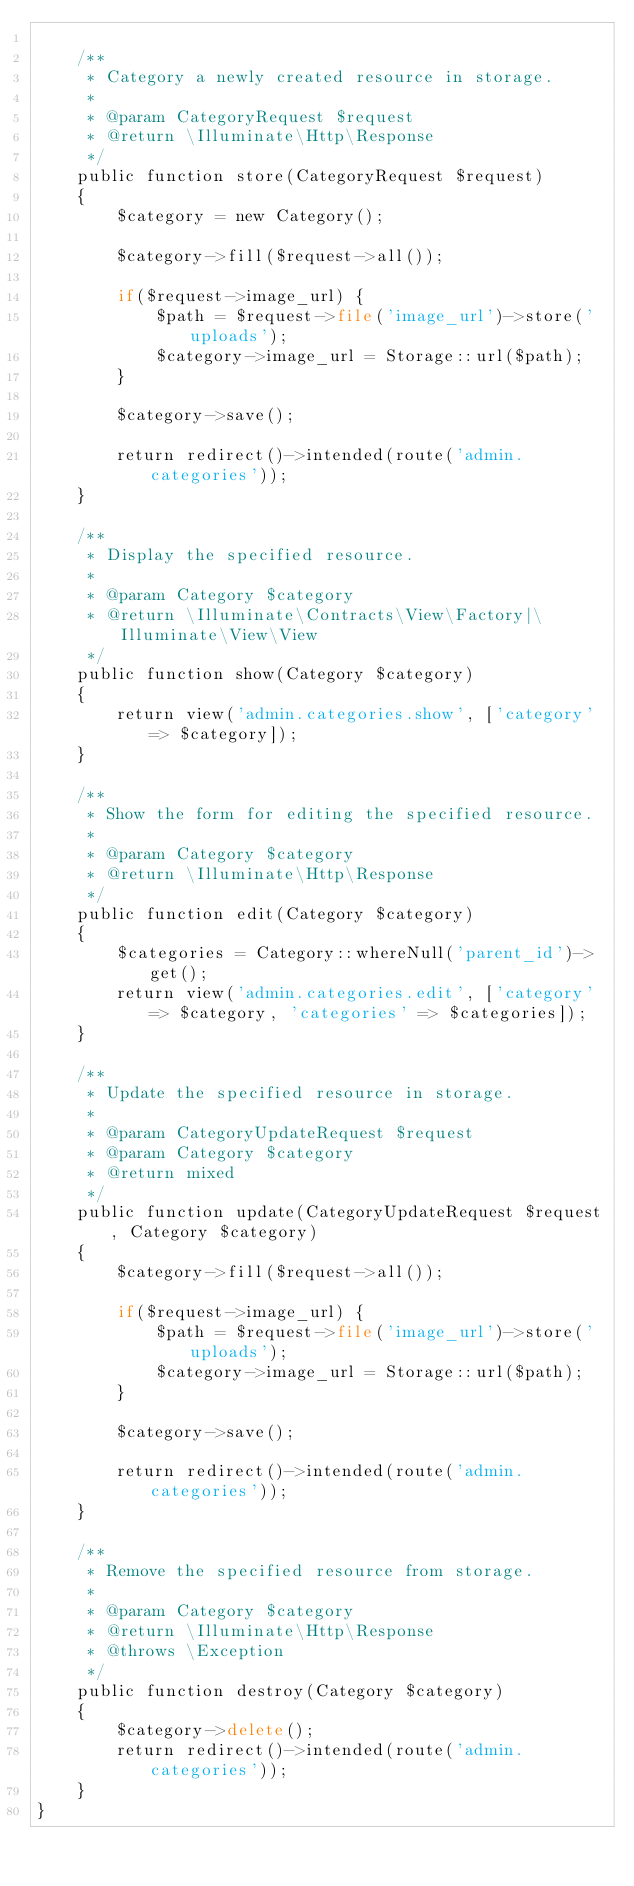<code> <loc_0><loc_0><loc_500><loc_500><_PHP_>
    /**
     * Category a newly created resource in storage.
     *
     * @param CategoryRequest $request
     * @return \Illuminate\Http\Response
     */
    public function store(CategoryRequest $request)
    {
        $category = new Category();

        $category->fill($request->all());

        if($request->image_url) {
            $path = $request->file('image_url')->store('uploads');
            $category->image_url = Storage::url($path);
        }

        $category->save();

        return redirect()->intended(route('admin.categories'));
    }

    /**
     * Display the specified resource.
     *
     * @param Category $category
     * @return \Illuminate\Contracts\View\Factory|\Illuminate\View\View
     */
    public function show(Category $category)
    {
        return view('admin.categories.show', ['category' => $category]);
    }

    /**
     * Show the form for editing the specified resource.
     *
     * @param Category $category
     * @return \Illuminate\Http\Response
     */
    public function edit(Category $category)
    {
        $categories = Category::whereNull('parent_id')->get();
        return view('admin.categories.edit', ['category' => $category, 'categories' => $categories]);
    }

    /**
     * Update the specified resource in storage.
     *
     * @param CategoryUpdateRequest $request
     * @param Category $category
     * @return mixed
     */
    public function update(CategoryUpdateRequest $request, Category $category)
    {
        $category->fill($request->all());

        if($request->image_url) {
            $path = $request->file('image_url')->store('uploads');
            $category->image_url = Storage::url($path);
        }

        $category->save();

        return redirect()->intended(route('admin.categories'));
    }

    /**
     * Remove the specified resource from storage.
     *
     * @param Category $category
     * @return \Illuminate\Http\Response
     * @throws \Exception
     */
    public function destroy(Category $category)
    {
        $category->delete();
        return redirect()->intended(route('admin.categories'));
    }
}
</code> 